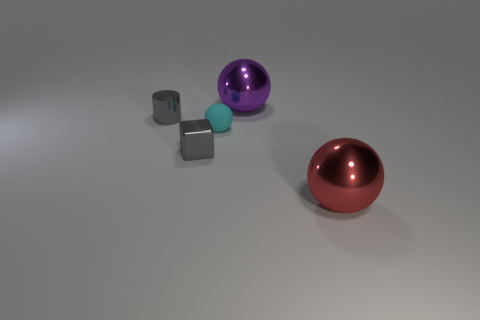Add 3 small metal objects. How many objects exist? 8 Subtract all blocks. How many objects are left? 4 Subtract all big blue shiny spheres. Subtract all small cyan rubber spheres. How many objects are left? 4 Add 1 small gray shiny blocks. How many small gray shiny blocks are left? 2 Add 3 tiny balls. How many tiny balls exist? 4 Subtract 0 blue cylinders. How many objects are left? 5 